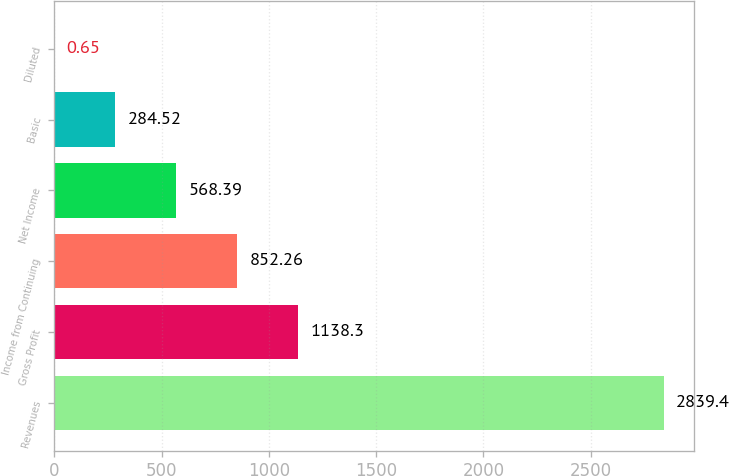<chart> <loc_0><loc_0><loc_500><loc_500><bar_chart><fcel>Revenues<fcel>Gross Profit<fcel>Income from Continuing<fcel>Net Income<fcel>Basic<fcel>Diluted<nl><fcel>2839.4<fcel>1138.3<fcel>852.26<fcel>568.39<fcel>284.52<fcel>0.65<nl></chart> 